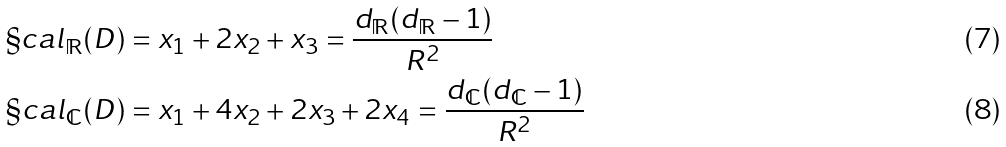<formula> <loc_0><loc_0><loc_500><loc_500>\S c a l _ { \mathbb { R } } ( D ) & = x _ { 1 } + 2 x _ { 2 } + x _ { 3 } = \frac { d _ { \mathbb { R } } ( d _ { \mathbb { R } } - 1 ) } { R ^ { 2 } } \\ \S c a l _ { \mathbb { C } } ( D ) & = x _ { 1 } + 4 x _ { 2 } + 2 x _ { 3 } + 2 x _ { 4 } = \frac { d _ { \mathbb { C } } ( d _ { \mathbb { C } } - 1 ) } { R ^ { 2 } }</formula> 